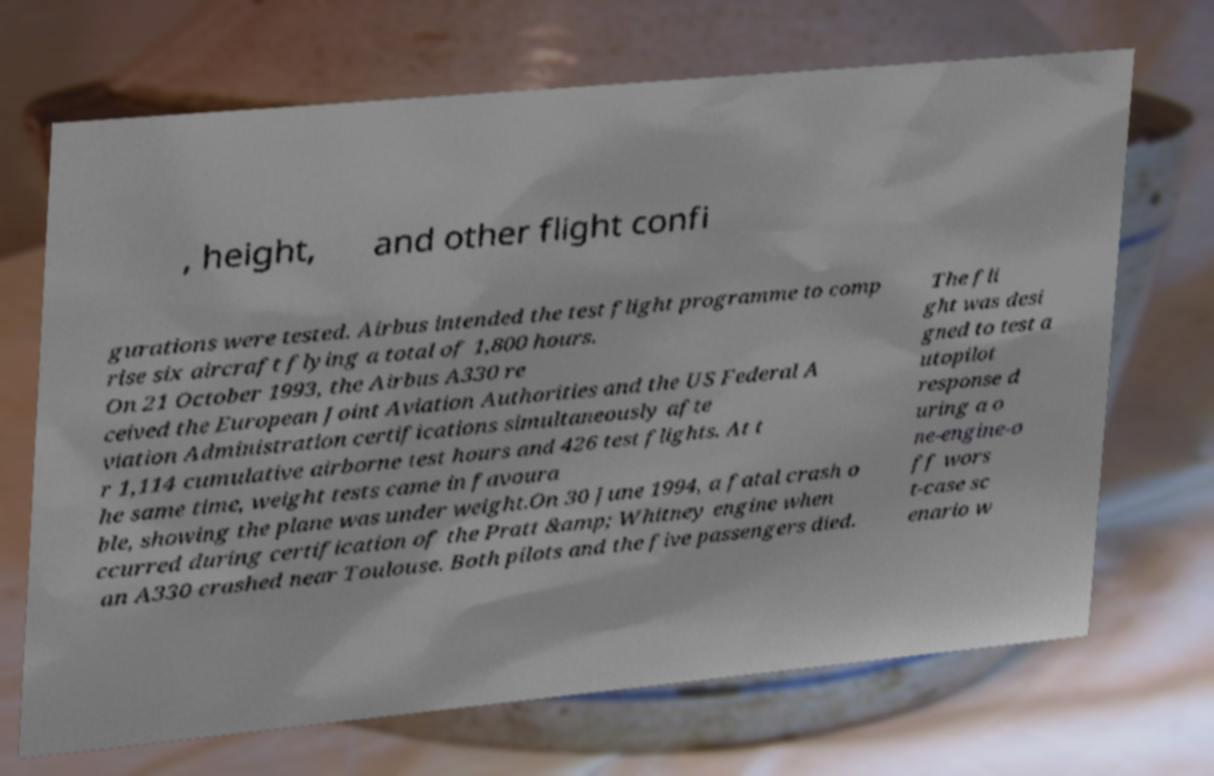For documentation purposes, I need the text within this image transcribed. Could you provide that? , height, and other flight confi gurations were tested. Airbus intended the test flight programme to comp rise six aircraft flying a total of 1,800 hours. On 21 October 1993, the Airbus A330 re ceived the European Joint Aviation Authorities and the US Federal A viation Administration certifications simultaneously afte r 1,114 cumulative airborne test hours and 426 test flights. At t he same time, weight tests came in favoura ble, showing the plane was under weight.On 30 June 1994, a fatal crash o ccurred during certification of the Pratt &amp; Whitney engine when an A330 crashed near Toulouse. Both pilots and the five passengers died. The fli ght was desi gned to test a utopilot response d uring a o ne-engine-o ff wors t-case sc enario w 